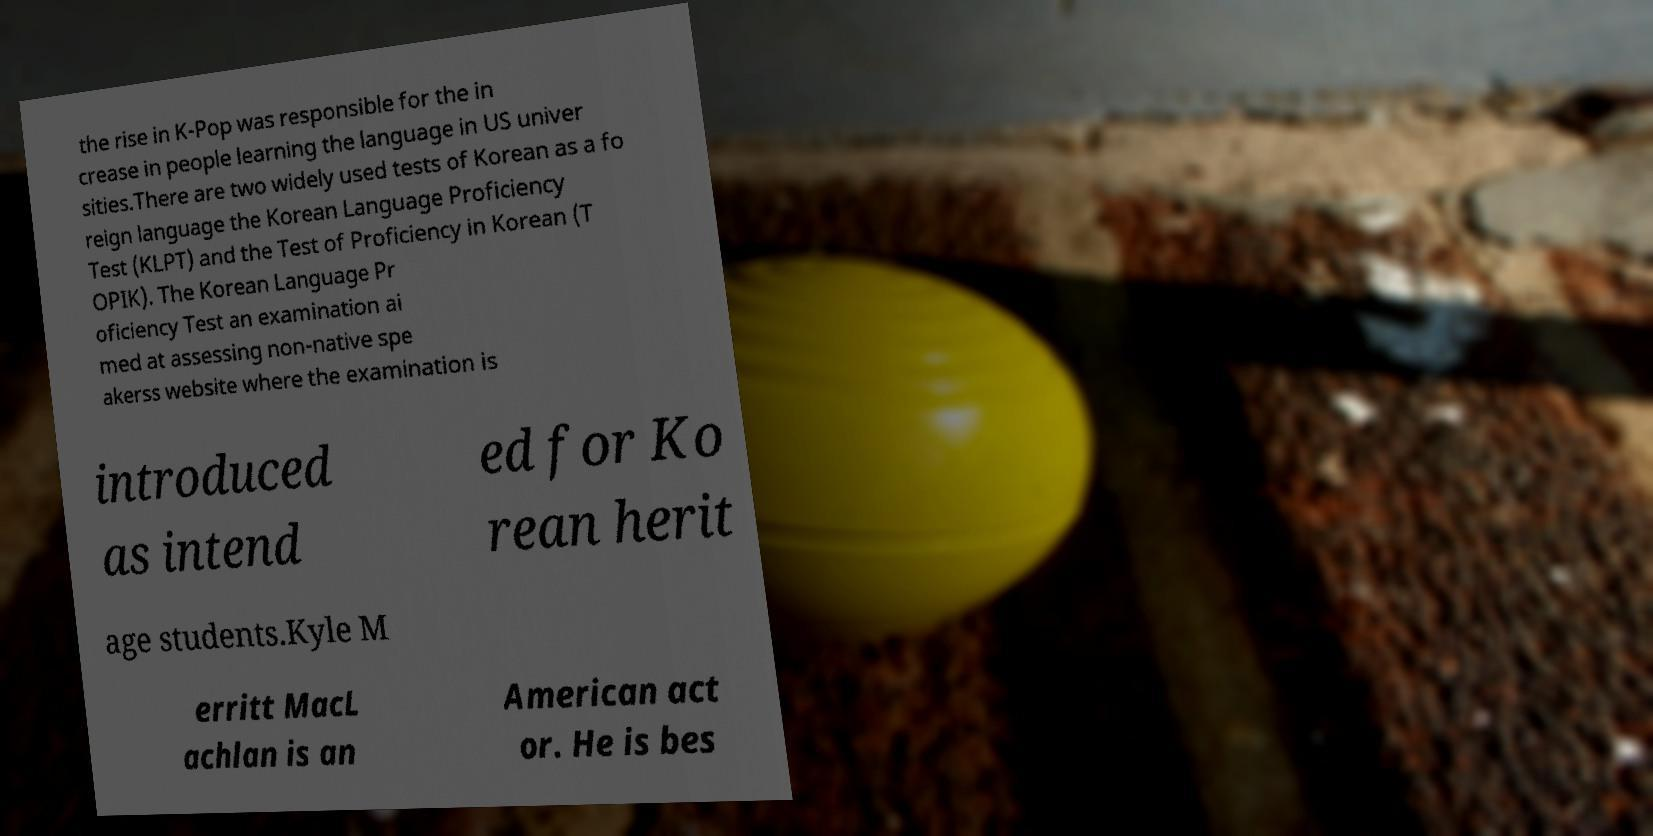Could you extract and type out the text from this image? the rise in K-Pop was responsible for the in crease in people learning the language in US univer sities.There are two widely used tests of Korean as a fo reign language the Korean Language Proficiency Test (KLPT) and the Test of Proficiency in Korean (T OPIK). The Korean Language Pr oficiency Test an examination ai med at assessing non-native spe akerss website where the examination is introduced as intend ed for Ko rean herit age students.Kyle M erritt MacL achlan is an American act or. He is bes 